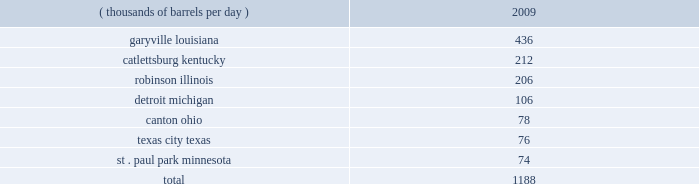Technical and research personnel and lab facilities , and significantly expanded the portfolio of patents available to us via license and through a cooperative development program .
In addition , we have acquired a 20 percent interest in grt , inc .
The gtftm technology is protected by an intellectual property protection program .
The u.s .
Has granted 17 patents for the technology , with another 22 pending .
Worldwide , there are over 300 patents issued or pending , covering over 100 countries including regional and direct foreign filings .
Another innovative technology that we are developing focuses on reducing the processing and transportation costs of natural gas by artificially creating natural gas hydrates , which are more easily transportable than natural gas in its gaseous form .
Much like lng , gas hydrates would then be regasified upon delivery to the receiving market .
We have an active pilot program in place to test and further develop a proprietary natural gas hydrates manufacturing system .
The above discussion of the integrated gas segment contains forward-looking statements with respect to the possible expansion of the lng production facility .
Factors that could potentially affect the possible expansion of the lng production facility include partner and government approvals , access to sufficient natural gas volumes through exploration or commercial negotiations with other resource owners and access to sufficient regasification capacity .
The foregoing factors ( among others ) could cause actual results to differ materially from those set forth in the forward-looking statements .
Refining , marketing and transportation we have refining , marketing and transportation operations concentrated primarily in the midwest , upper great plains , gulf coast and southeast regions of the u.s .
We rank as the fifth largest crude oil refiner in the u.s .
And the largest in the midwest .
Our operations include a seven-plant refining network and an integrated terminal and transportation system which supplies wholesale and marathon-brand customers as well as our own retail operations .
Our wholly-owned retail marketing subsidiary speedway superamerica llc ( 201cssa 201d ) is the third largest chain of company-owned and -operated retail gasoline and convenience stores in the u.s .
And the largest in the midwest .
Refining we own and operate seven refineries with an aggregate refining capacity of 1.188 million barrels per day ( 201cmmbpd 201d ) of crude oil as of december 31 , 2009 .
During 2009 , our refineries processed 957 mbpd of crude oil and 196 mbpd of other charge and blend stocks .
The table below sets forth the location and daily crude oil refining capacity of each of our refineries as of december 31 , 2009 .
Crude oil refining capacity ( thousands of barrels per day ) 2009 .
Our refineries include crude oil atmospheric and vacuum distillation , fluid catalytic cracking , catalytic reforming , desulfurization and sulfur recovery units .
The refineries process a wide variety of crude oils and produce numerous refined products , ranging from transportation fuels , such as reformulated gasolines , blend- grade gasolines intended for blending with fuel ethanol and ultra-low sulfur diesel fuel , to heavy fuel oil and asphalt .
Additionally , we manufacture aromatics , cumene , propane , propylene , sulfur and maleic anhydride .
Our garyville , louisiana , refinery is located along the mississippi river in southeastern louisiana between new orleans and baton rouge .
The garyville refinery predominantly processes heavy sour crude oil into products .
During 2009 , refineries a total of how much processed total crude and other charge and blend stocks , in mbpd? 
Computations: (957 + 196)
Answer: 1153.0. Technical and research personnel and lab facilities , and significantly expanded the portfolio of patents available to us via license and through a cooperative development program .
In addition , we have acquired a 20 percent interest in grt , inc .
The gtftm technology is protected by an intellectual property protection program .
The u.s .
Has granted 17 patents for the technology , with another 22 pending .
Worldwide , there are over 300 patents issued or pending , covering over 100 countries including regional and direct foreign filings .
Another innovative technology that we are developing focuses on reducing the processing and transportation costs of natural gas by artificially creating natural gas hydrates , which are more easily transportable than natural gas in its gaseous form .
Much like lng , gas hydrates would then be regasified upon delivery to the receiving market .
We have an active pilot program in place to test and further develop a proprietary natural gas hydrates manufacturing system .
The above discussion of the integrated gas segment contains forward-looking statements with respect to the possible expansion of the lng production facility .
Factors that could potentially affect the possible expansion of the lng production facility include partner and government approvals , access to sufficient natural gas volumes through exploration or commercial negotiations with other resource owners and access to sufficient regasification capacity .
The foregoing factors ( among others ) could cause actual results to differ materially from those set forth in the forward-looking statements .
Refining , marketing and transportation we have refining , marketing and transportation operations concentrated primarily in the midwest , upper great plains , gulf coast and southeast regions of the u.s .
We rank as the fifth largest crude oil refiner in the u.s .
And the largest in the midwest .
Our operations include a seven-plant refining network and an integrated terminal and transportation system which supplies wholesale and marathon-brand customers as well as our own retail operations .
Our wholly-owned retail marketing subsidiary speedway superamerica llc ( 201cssa 201d ) is the third largest chain of company-owned and -operated retail gasoline and convenience stores in the u.s .
And the largest in the midwest .
Refining we own and operate seven refineries with an aggregate refining capacity of 1.188 million barrels per day ( 201cmmbpd 201d ) of crude oil as of december 31 , 2009 .
During 2009 , our refineries processed 957 mbpd of crude oil and 196 mbpd of other charge and blend stocks .
The table below sets forth the location and daily crude oil refining capacity of each of our refineries as of december 31 , 2009 .
Crude oil refining capacity ( thousands of barrels per day ) 2009 .
Our refineries include crude oil atmospheric and vacuum distillation , fluid catalytic cracking , catalytic reforming , desulfurization and sulfur recovery units .
The refineries process a wide variety of crude oils and produce numerous refined products , ranging from transportation fuels , such as reformulated gasolines , blend- grade gasolines intended for blending with fuel ethanol and ultra-low sulfur diesel fuel , to heavy fuel oil and asphalt .
Additionally , we manufacture aromatics , cumene , propane , propylene , sulfur and maleic anhydride .
Our garyville , louisiana , refinery is located along the mississippi river in southeastern louisiana between new orleans and baton rouge .
The garyville refinery predominantly processes heavy sour crude oil into products .
What percentage of crude oil refining capacity is located in catlettsburg kentucky? 
Computations: (212 / 1188)
Answer: 0.17845. 